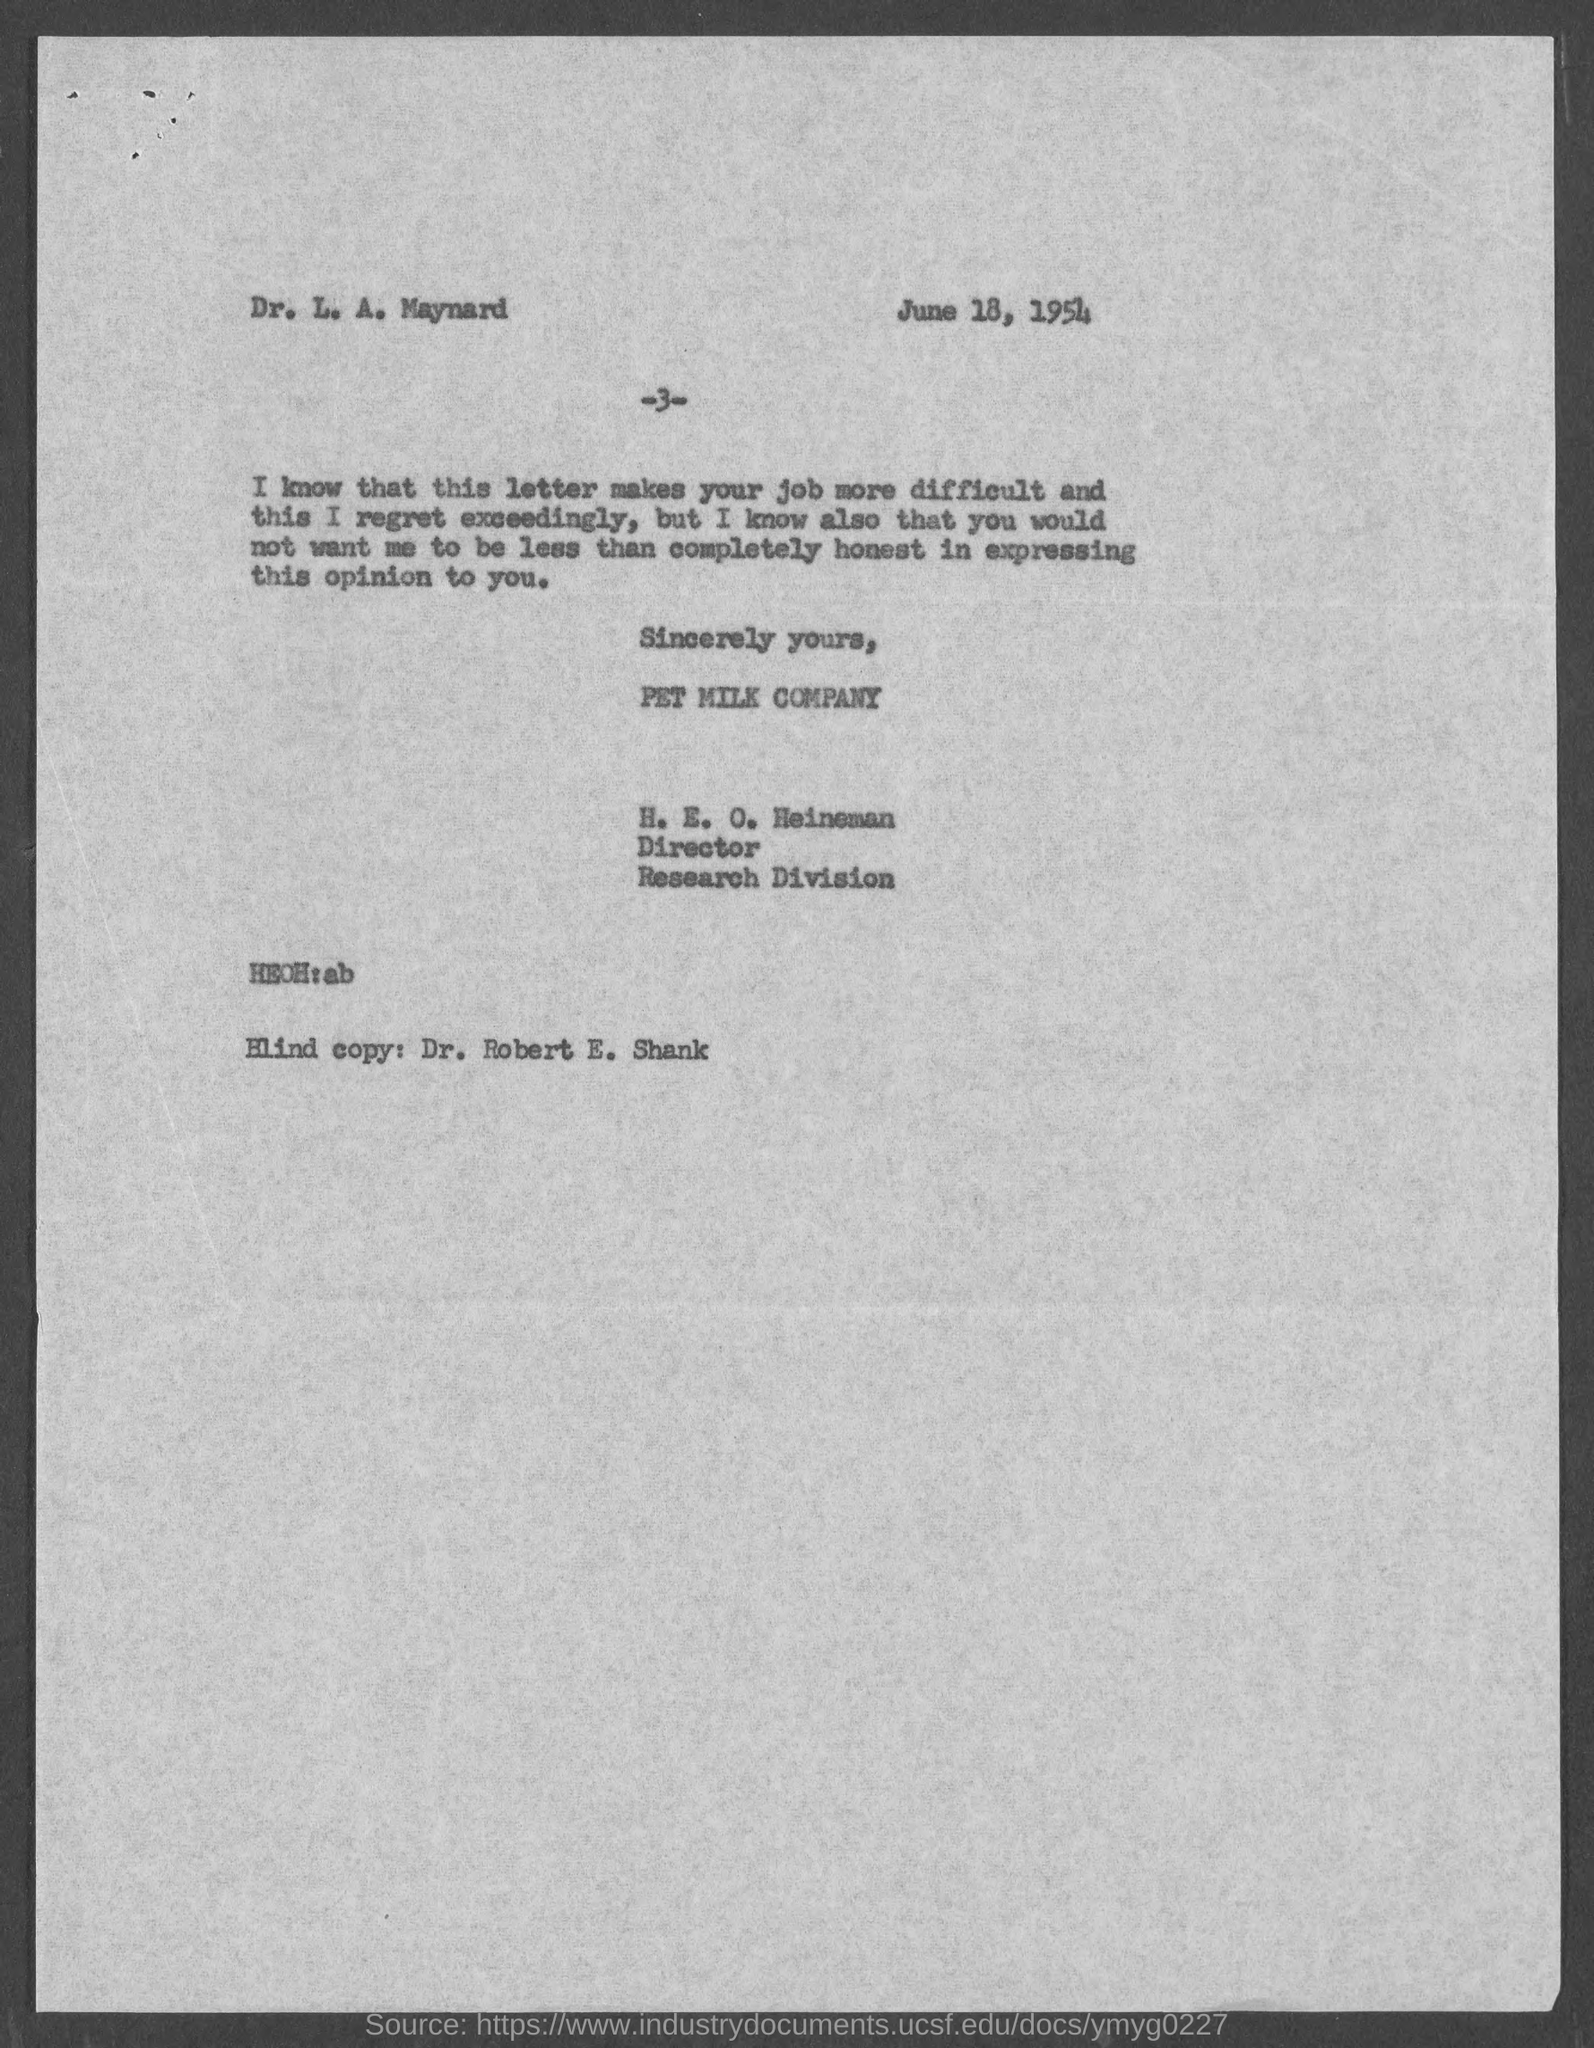Outline some significant characteristics in this image. The copy of the document marked "The Blind" was sent to Robert E. Shank. 